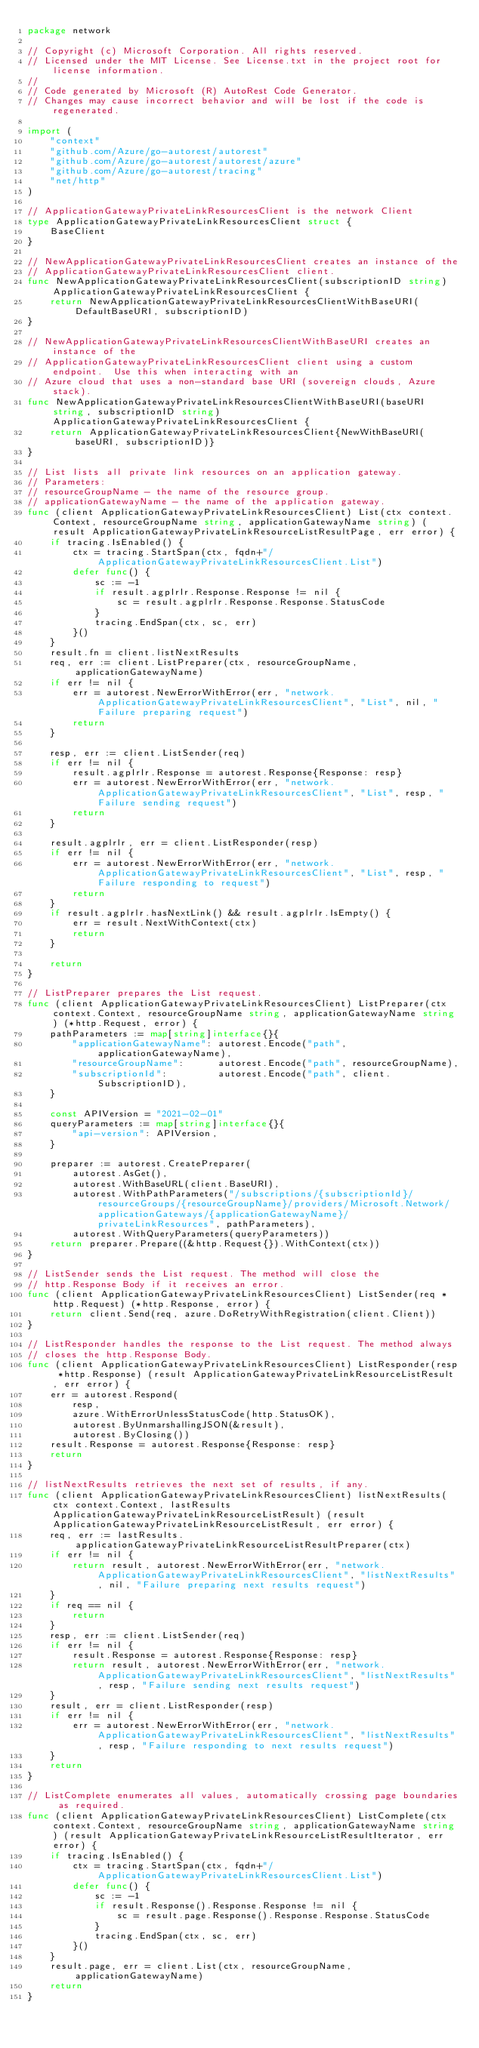<code> <loc_0><loc_0><loc_500><loc_500><_Go_>package network

// Copyright (c) Microsoft Corporation. All rights reserved.
// Licensed under the MIT License. See License.txt in the project root for license information.
//
// Code generated by Microsoft (R) AutoRest Code Generator.
// Changes may cause incorrect behavior and will be lost if the code is regenerated.

import (
	"context"
	"github.com/Azure/go-autorest/autorest"
	"github.com/Azure/go-autorest/autorest/azure"
	"github.com/Azure/go-autorest/tracing"
	"net/http"
)

// ApplicationGatewayPrivateLinkResourcesClient is the network Client
type ApplicationGatewayPrivateLinkResourcesClient struct {
	BaseClient
}

// NewApplicationGatewayPrivateLinkResourcesClient creates an instance of the
// ApplicationGatewayPrivateLinkResourcesClient client.
func NewApplicationGatewayPrivateLinkResourcesClient(subscriptionID string) ApplicationGatewayPrivateLinkResourcesClient {
	return NewApplicationGatewayPrivateLinkResourcesClientWithBaseURI(DefaultBaseURI, subscriptionID)
}

// NewApplicationGatewayPrivateLinkResourcesClientWithBaseURI creates an instance of the
// ApplicationGatewayPrivateLinkResourcesClient client using a custom endpoint.  Use this when interacting with an
// Azure cloud that uses a non-standard base URI (sovereign clouds, Azure stack).
func NewApplicationGatewayPrivateLinkResourcesClientWithBaseURI(baseURI string, subscriptionID string) ApplicationGatewayPrivateLinkResourcesClient {
	return ApplicationGatewayPrivateLinkResourcesClient{NewWithBaseURI(baseURI, subscriptionID)}
}

// List lists all private link resources on an application gateway.
// Parameters:
// resourceGroupName - the name of the resource group.
// applicationGatewayName - the name of the application gateway.
func (client ApplicationGatewayPrivateLinkResourcesClient) List(ctx context.Context, resourceGroupName string, applicationGatewayName string) (result ApplicationGatewayPrivateLinkResourceListResultPage, err error) {
	if tracing.IsEnabled() {
		ctx = tracing.StartSpan(ctx, fqdn+"/ApplicationGatewayPrivateLinkResourcesClient.List")
		defer func() {
			sc := -1
			if result.agplrlr.Response.Response != nil {
				sc = result.agplrlr.Response.Response.StatusCode
			}
			tracing.EndSpan(ctx, sc, err)
		}()
	}
	result.fn = client.listNextResults
	req, err := client.ListPreparer(ctx, resourceGroupName, applicationGatewayName)
	if err != nil {
		err = autorest.NewErrorWithError(err, "network.ApplicationGatewayPrivateLinkResourcesClient", "List", nil, "Failure preparing request")
		return
	}

	resp, err := client.ListSender(req)
	if err != nil {
		result.agplrlr.Response = autorest.Response{Response: resp}
		err = autorest.NewErrorWithError(err, "network.ApplicationGatewayPrivateLinkResourcesClient", "List", resp, "Failure sending request")
		return
	}

	result.agplrlr, err = client.ListResponder(resp)
	if err != nil {
		err = autorest.NewErrorWithError(err, "network.ApplicationGatewayPrivateLinkResourcesClient", "List", resp, "Failure responding to request")
		return
	}
	if result.agplrlr.hasNextLink() && result.agplrlr.IsEmpty() {
		err = result.NextWithContext(ctx)
		return
	}

	return
}

// ListPreparer prepares the List request.
func (client ApplicationGatewayPrivateLinkResourcesClient) ListPreparer(ctx context.Context, resourceGroupName string, applicationGatewayName string) (*http.Request, error) {
	pathParameters := map[string]interface{}{
		"applicationGatewayName": autorest.Encode("path", applicationGatewayName),
		"resourceGroupName":      autorest.Encode("path", resourceGroupName),
		"subscriptionId":         autorest.Encode("path", client.SubscriptionID),
	}

	const APIVersion = "2021-02-01"
	queryParameters := map[string]interface{}{
		"api-version": APIVersion,
	}

	preparer := autorest.CreatePreparer(
		autorest.AsGet(),
		autorest.WithBaseURL(client.BaseURI),
		autorest.WithPathParameters("/subscriptions/{subscriptionId}/resourceGroups/{resourceGroupName}/providers/Microsoft.Network/applicationGateways/{applicationGatewayName}/privateLinkResources", pathParameters),
		autorest.WithQueryParameters(queryParameters))
	return preparer.Prepare((&http.Request{}).WithContext(ctx))
}

// ListSender sends the List request. The method will close the
// http.Response Body if it receives an error.
func (client ApplicationGatewayPrivateLinkResourcesClient) ListSender(req *http.Request) (*http.Response, error) {
	return client.Send(req, azure.DoRetryWithRegistration(client.Client))
}

// ListResponder handles the response to the List request. The method always
// closes the http.Response Body.
func (client ApplicationGatewayPrivateLinkResourcesClient) ListResponder(resp *http.Response) (result ApplicationGatewayPrivateLinkResourceListResult, err error) {
	err = autorest.Respond(
		resp,
		azure.WithErrorUnlessStatusCode(http.StatusOK),
		autorest.ByUnmarshallingJSON(&result),
		autorest.ByClosing())
	result.Response = autorest.Response{Response: resp}
	return
}

// listNextResults retrieves the next set of results, if any.
func (client ApplicationGatewayPrivateLinkResourcesClient) listNextResults(ctx context.Context, lastResults ApplicationGatewayPrivateLinkResourceListResult) (result ApplicationGatewayPrivateLinkResourceListResult, err error) {
	req, err := lastResults.applicationGatewayPrivateLinkResourceListResultPreparer(ctx)
	if err != nil {
		return result, autorest.NewErrorWithError(err, "network.ApplicationGatewayPrivateLinkResourcesClient", "listNextResults", nil, "Failure preparing next results request")
	}
	if req == nil {
		return
	}
	resp, err := client.ListSender(req)
	if err != nil {
		result.Response = autorest.Response{Response: resp}
		return result, autorest.NewErrorWithError(err, "network.ApplicationGatewayPrivateLinkResourcesClient", "listNextResults", resp, "Failure sending next results request")
	}
	result, err = client.ListResponder(resp)
	if err != nil {
		err = autorest.NewErrorWithError(err, "network.ApplicationGatewayPrivateLinkResourcesClient", "listNextResults", resp, "Failure responding to next results request")
	}
	return
}

// ListComplete enumerates all values, automatically crossing page boundaries as required.
func (client ApplicationGatewayPrivateLinkResourcesClient) ListComplete(ctx context.Context, resourceGroupName string, applicationGatewayName string) (result ApplicationGatewayPrivateLinkResourceListResultIterator, err error) {
	if tracing.IsEnabled() {
		ctx = tracing.StartSpan(ctx, fqdn+"/ApplicationGatewayPrivateLinkResourcesClient.List")
		defer func() {
			sc := -1
			if result.Response().Response.Response != nil {
				sc = result.page.Response().Response.Response.StatusCode
			}
			tracing.EndSpan(ctx, sc, err)
		}()
	}
	result.page, err = client.List(ctx, resourceGroupName, applicationGatewayName)
	return
}
</code> 